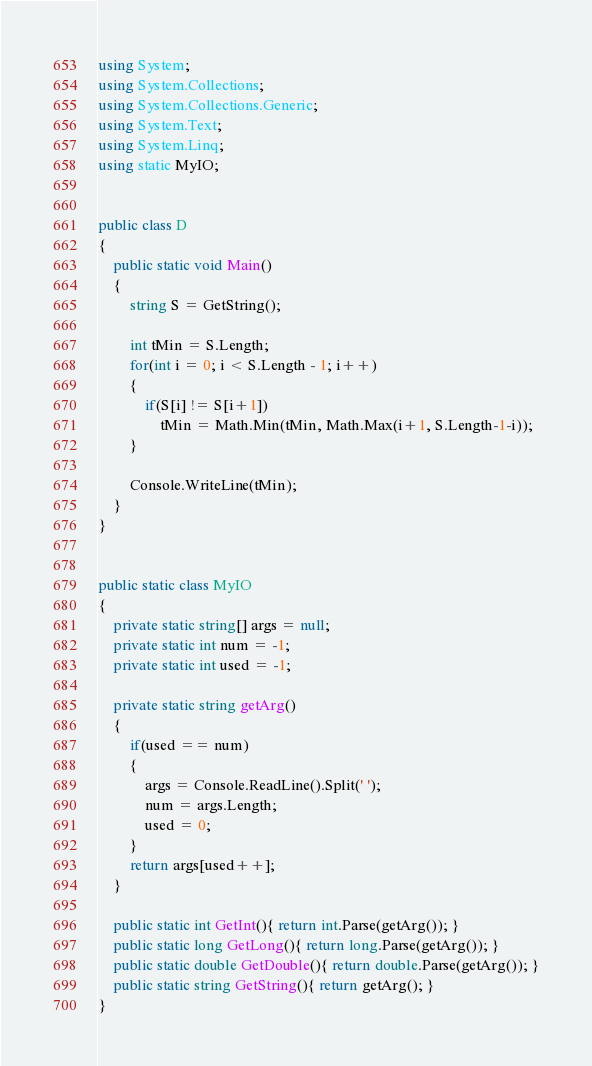Convert code to text. <code><loc_0><loc_0><loc_500><loc_500><_C#_>using System;
using System.Collections;
using System.Collections.Generic;
using System.Text;
using System.Linq;
using static MyIO;


public class D
{
	public static void Main()
	{
		string S = GetString();

		int tMin = S.Length;
		for(int i = 0; i < S.Length - 1; i++)
		{
			if(S[i] != S[i+1])
				tMin = Math.Min(tMin, Math.Max(i+1, S.Length-1-i));
		}
		
		Console.WriteLine(tMin);
	}
}


public static class MyIO
{
	private static string[] args = null;
	private static int num = -1;
	private static int used = -1;

	private static string getArg()
	{
		if(used == num)
		{
			args = Console.ReadLine().Split(' ');
			num = args.Length;
			used = 0;
		}
		return args[used++];
	}

	public static int GetInt(){ return int.Parse(getArg()); }
	public static long GetLong(){ return long.Parse(getArg()); }
	public static double GetDouble(){ return double.Parse(getArg()); }
	public static string GetString(){ return getArg(); }
}</code> 